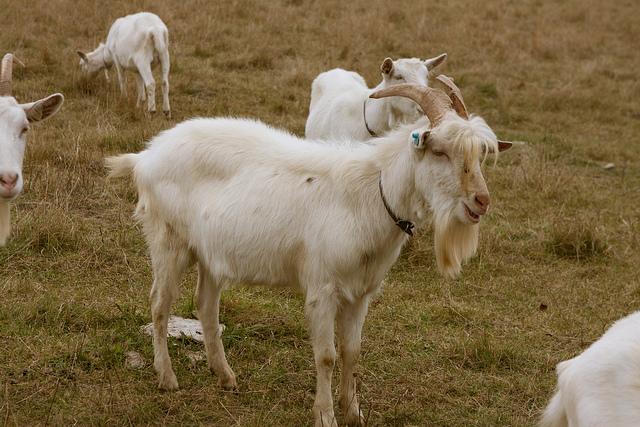Is the grass dying?
Concise answer only. Yes. Is this a baby goat?
Keep it brief. No. How many goats are here?
Be succinct. 5. 